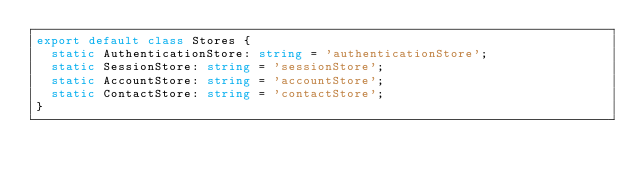Convert code to text. <code><loc_0><loc_0><loc_500><loc_500><_TypeScript_>export default class Stores {
  static AuthenticationStore: string = 'authenticationStore';
  static SessionStore: string = 'sessionStore';
  static AccountStore: string = 'accountStore';
  static ContactStore: string = 'contactStore';
}
</code> 